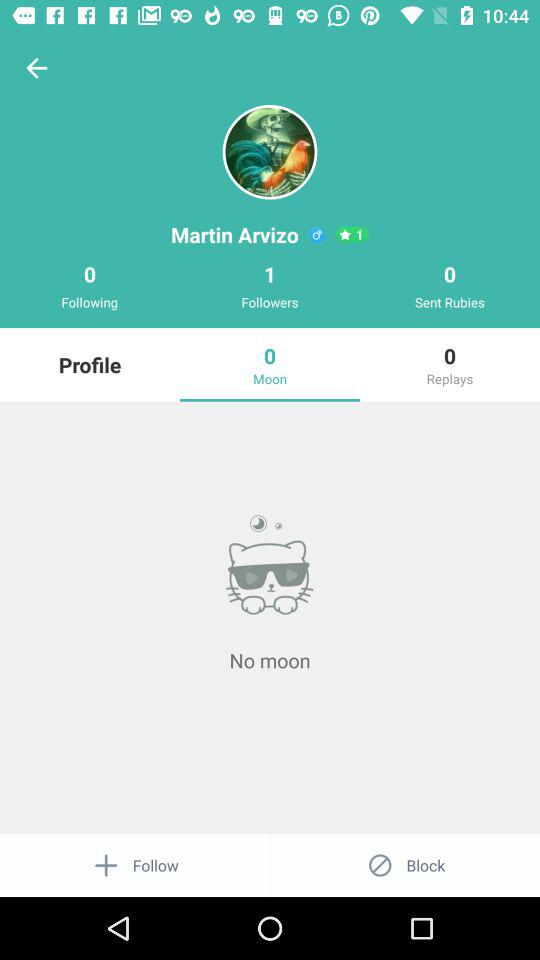What is the name of the user? The user name is Martin Arvizo. 